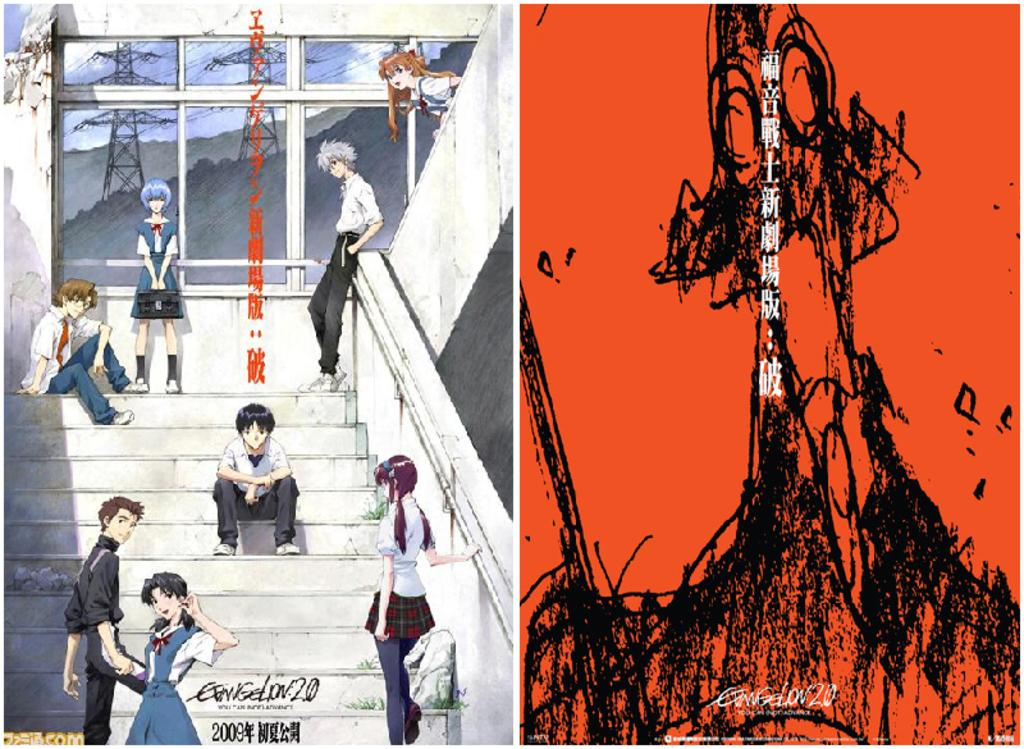<image>
Describe the image concisely. Two Japanese comics, the one on the right being Evangelion 2.0. 